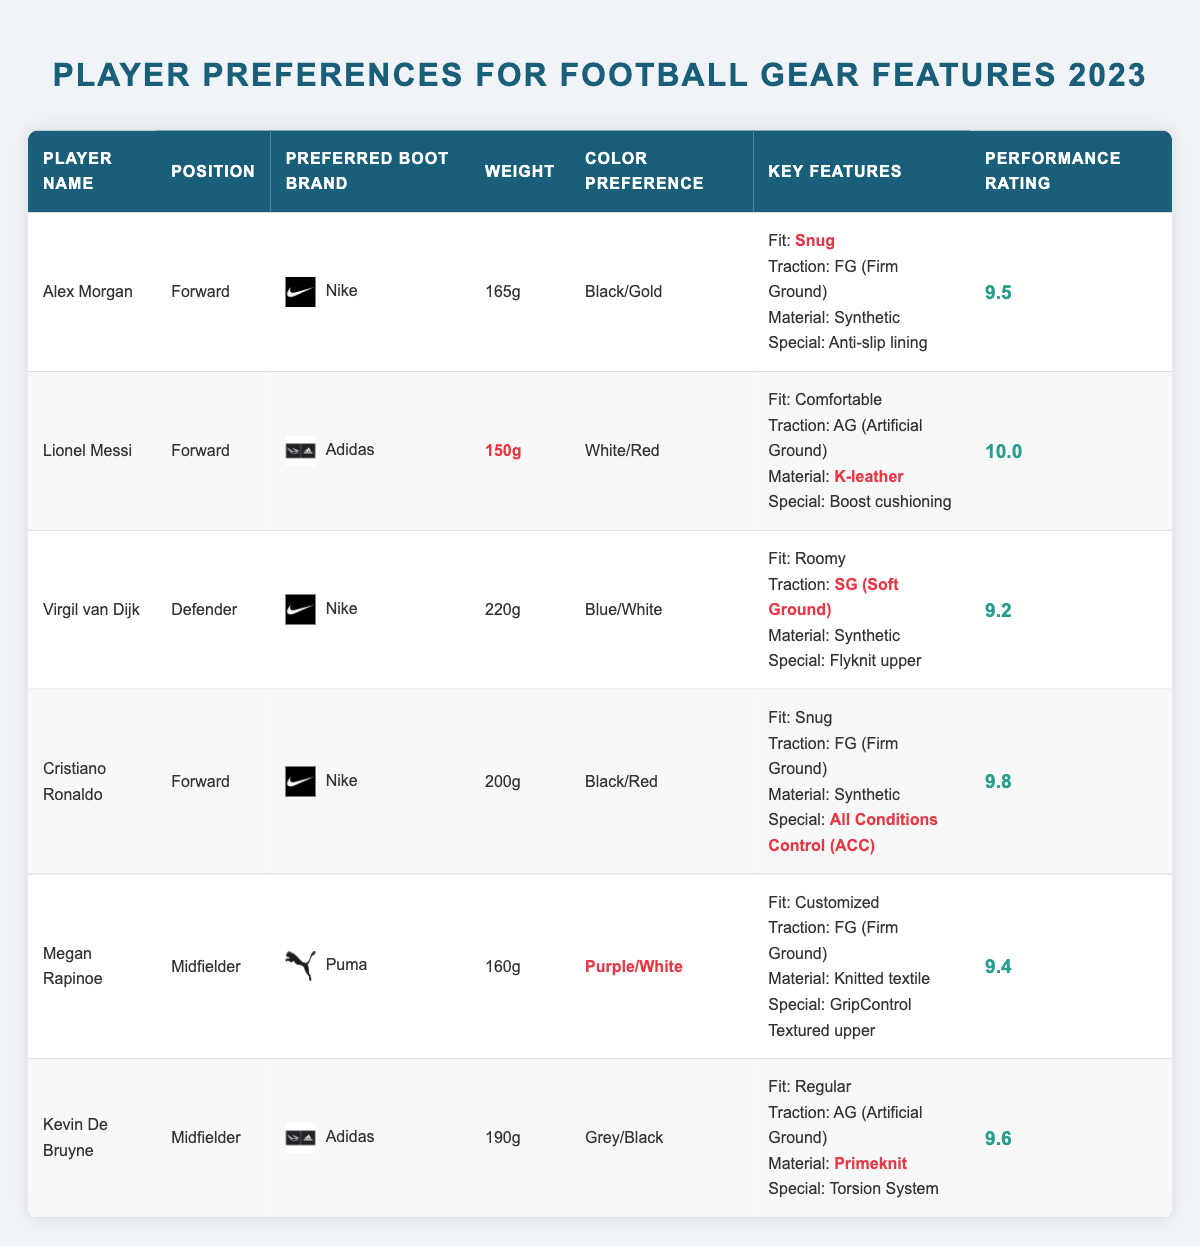What is the preferred boot brand of Virgil van Dijk? The table lists the preferred boot brands for each player, and for Virgil van Dijk, it states "Nike."
Answer: Nike Who has the highest performance rating among the players? The performance ratings for each player are shown in the last column. Lionel Messi has the highest rating at 10.0.
Answer: Lionel Messi What is Alex Morgan's weight preference for boots? The weight information for Alex Morgan can be found in the "Weight" column, which shows her weight preference as "165g."
Answer: 165g Which player prefers K-leather material for their boots? By examining the material preferences listed, Lionel Messi specifically prefers "K-leather."
Answer: Lionel Messi How many players have a performance rating of 9.5 or higher? The ratings are: 9.5 (Alex Morgan), 10.0 (Lionel Messi), 9.8 (Cristiano Ronaldo), 9.6 (Kevin De Bruyne), and 9.4 (Megan Rapinoe). That gives us four players above 9.5.
Answer: 4 players Is it true that all forwards have a snug fit preference? Looking at the fit preferences: Alex Morgan (Snug), Lionel Messi (Comfortable), and Cristiano Ronaldo (Snug) show that not all forwards have a snug fit preference.
Answer: No What is the total weight of the boots preferred by all midfielders? The weights for midfielders (Megan Rapinoe - 160g and Kevin De Bruyne - 190g) are summed up: 160g + 190g = 350g.
Answer: 350g Which color preference is the most common among the players? The color choices listed are: Black/Gold (Alex Morgan), White/Red (Lionel Messi), Blue/White (Virgil van Dijk), Black/Red (Cristiano Ronaldo), Purple/White (Megan Rapinoe), Grey/Black (Kevin De Bruyne). There is no repetition; hence, no common preference.
Answer: No common preference What is the average performance rating for all players listed? To compute the average, we sum the ratings: 9.5 + 10.0 + 9.2 + 9.8 + 9.4 + 9.6 = 57.5, and divide by 6 (total players): 57.5 / 6 = 9.58.
Answer: 9.58 Which player is the heaviest based on their preferred boot weight? The weights are as follows: Alex Morgan (165g), Lionel Messi (150g), Virgil van Dijk (220g), Cristiano Ronaldo (200g), Megan Rapinoe (160g), and Kevin De Bruyne (190g). Virgil van Dijk has the highest weight at 220g.
Answer: Virgil van Dijk 